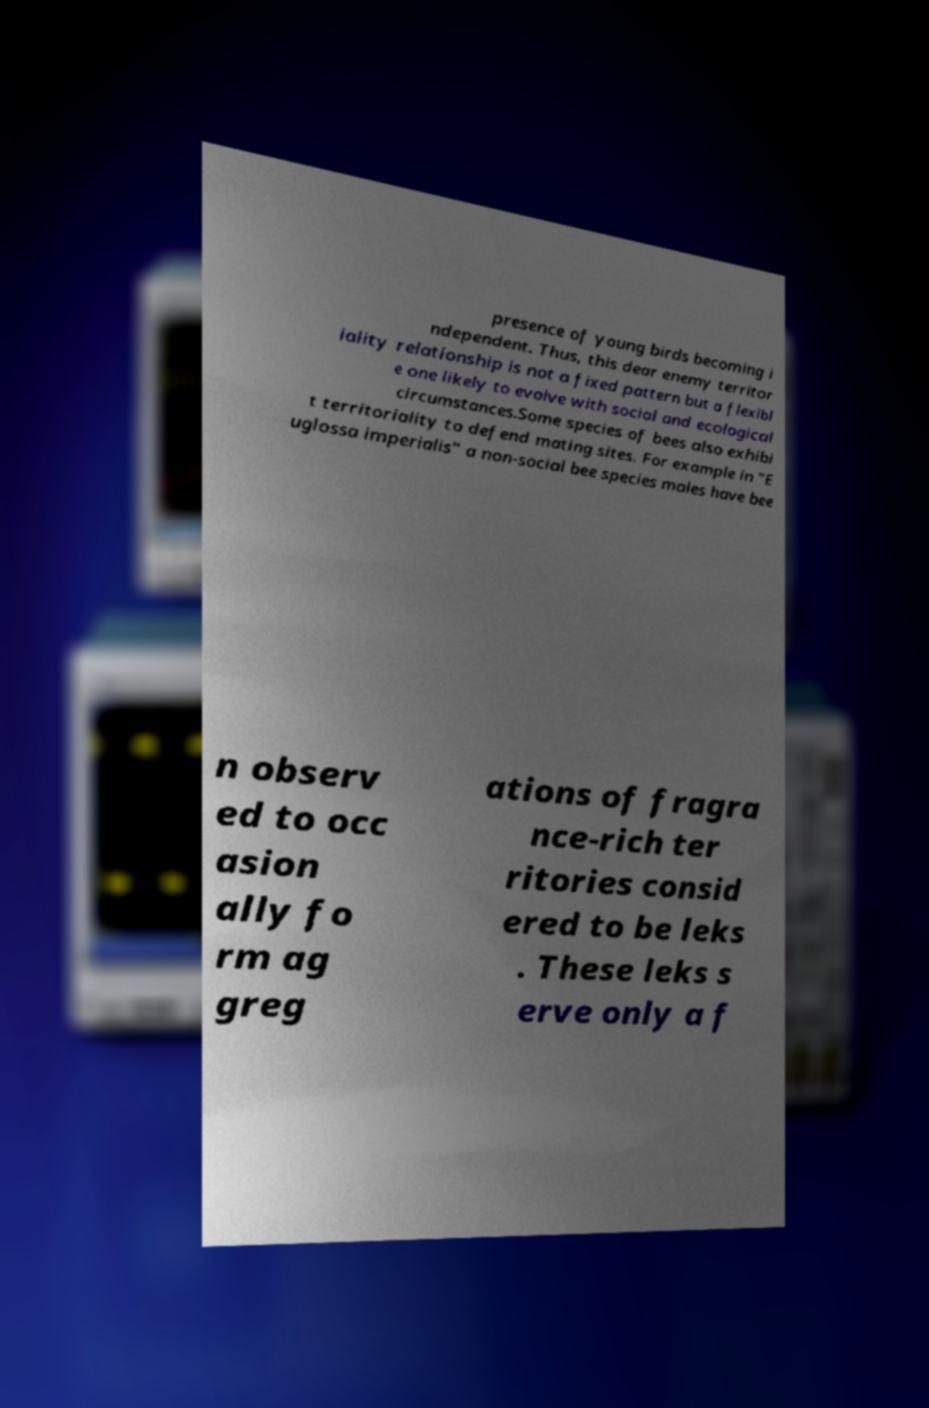Could you extract and type out the text from this image? presence of young birds becoming i ndependent. Thus, this dear enemy territor iality relationship is not a fixed pattern but a flexibl e one likely to evolve with social and ecological circumstances.Some species of bees also exhibi t territoriality to defend mating sites. For example in "E uglossa imperialis" a non-social bee species males have bee n observ ed to occ asion ally fo rm ag greg ations of fragra nce-rich ter ritories consid ered to be leks . These leks s erve only a f 